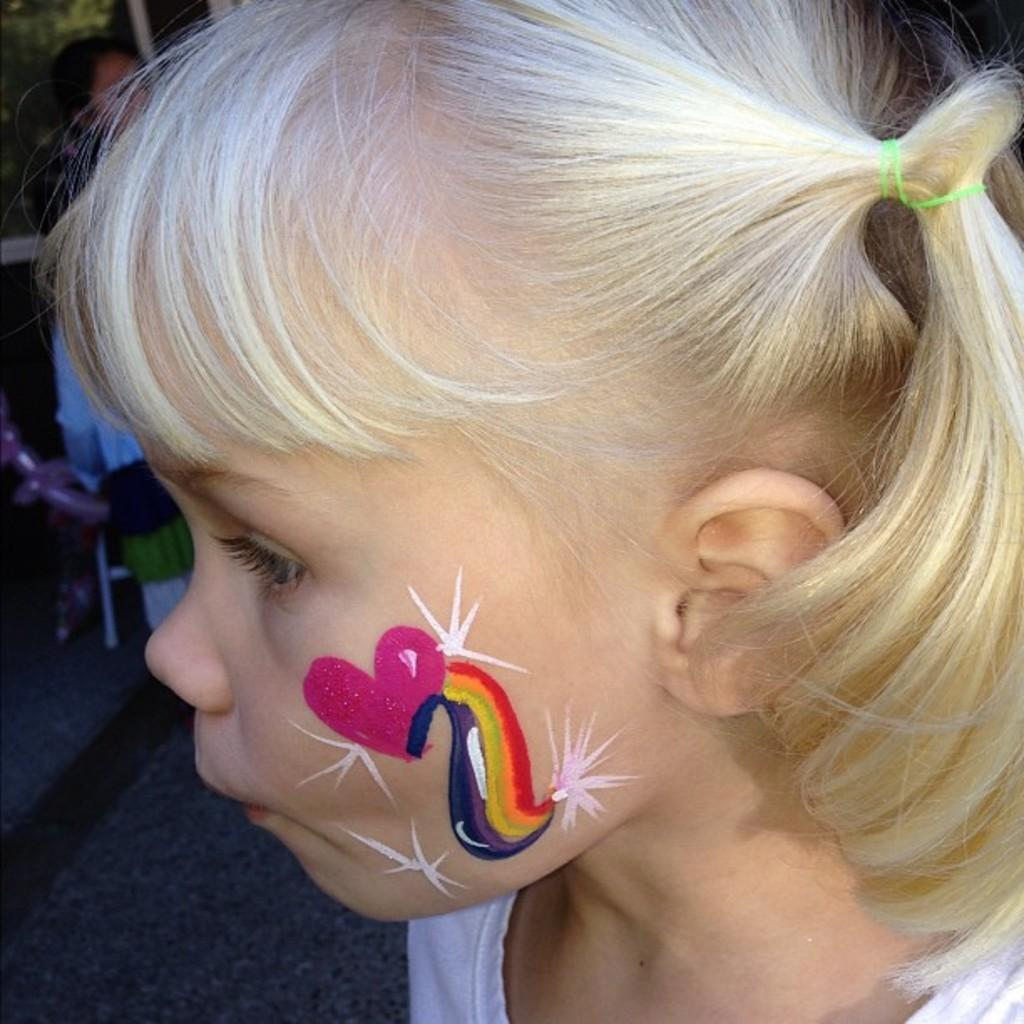What is the main subject of the image? There is a girl's face in the image. What decorations are on her cheeks? A pink heart and stars are painted on her cheeks. What colors are used for the decorations on her cheeks? Colors are painted on her cheeks. What can be seen in the background of the image? There are trees and people on the road in the background of the image. How does the girl's face contribute to the growth of the trees in the background? The girl's face does not contribute to the growth of the trees in the background; it is a separate subject in the image. 